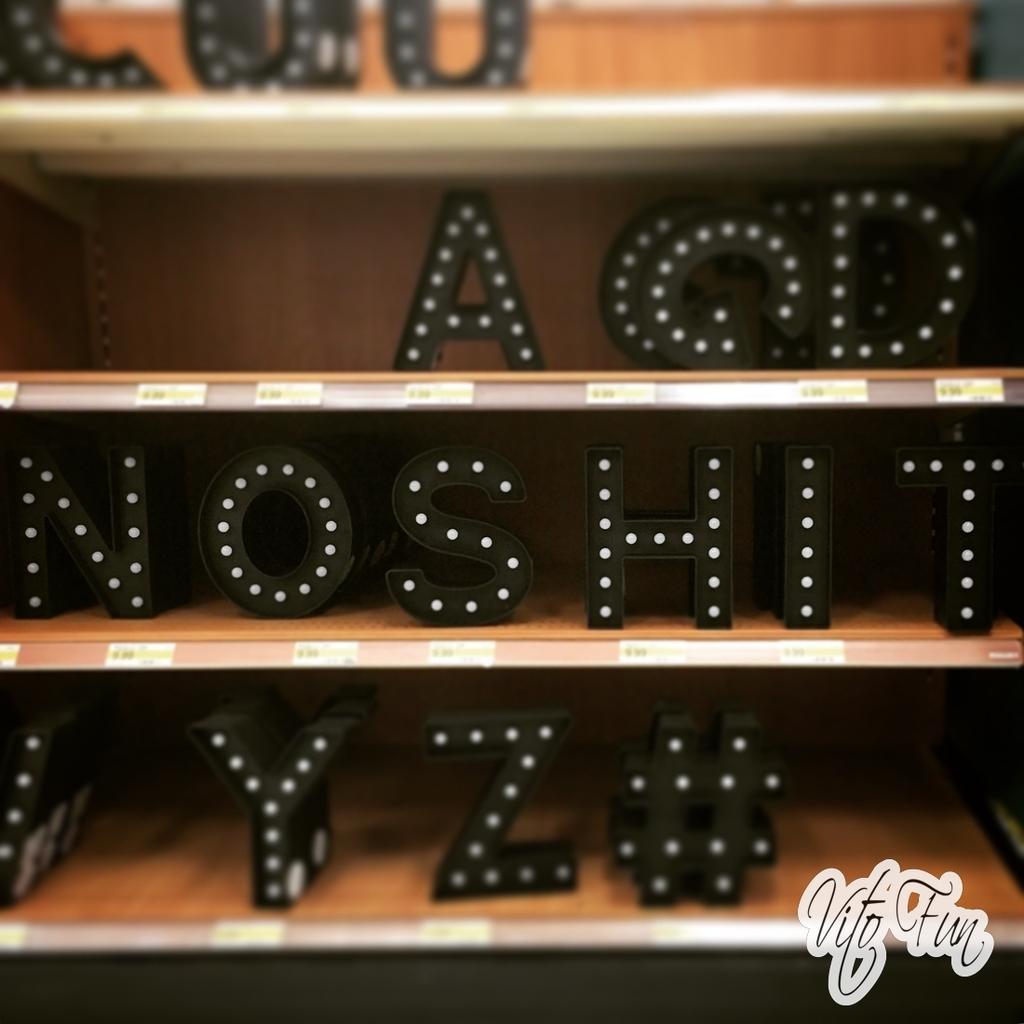Could you give a brief overview of what you see in this image? In this image we see shelf's which consists of alphabets and there are stickers on the shelves, at the bottom right corner there is some text. 